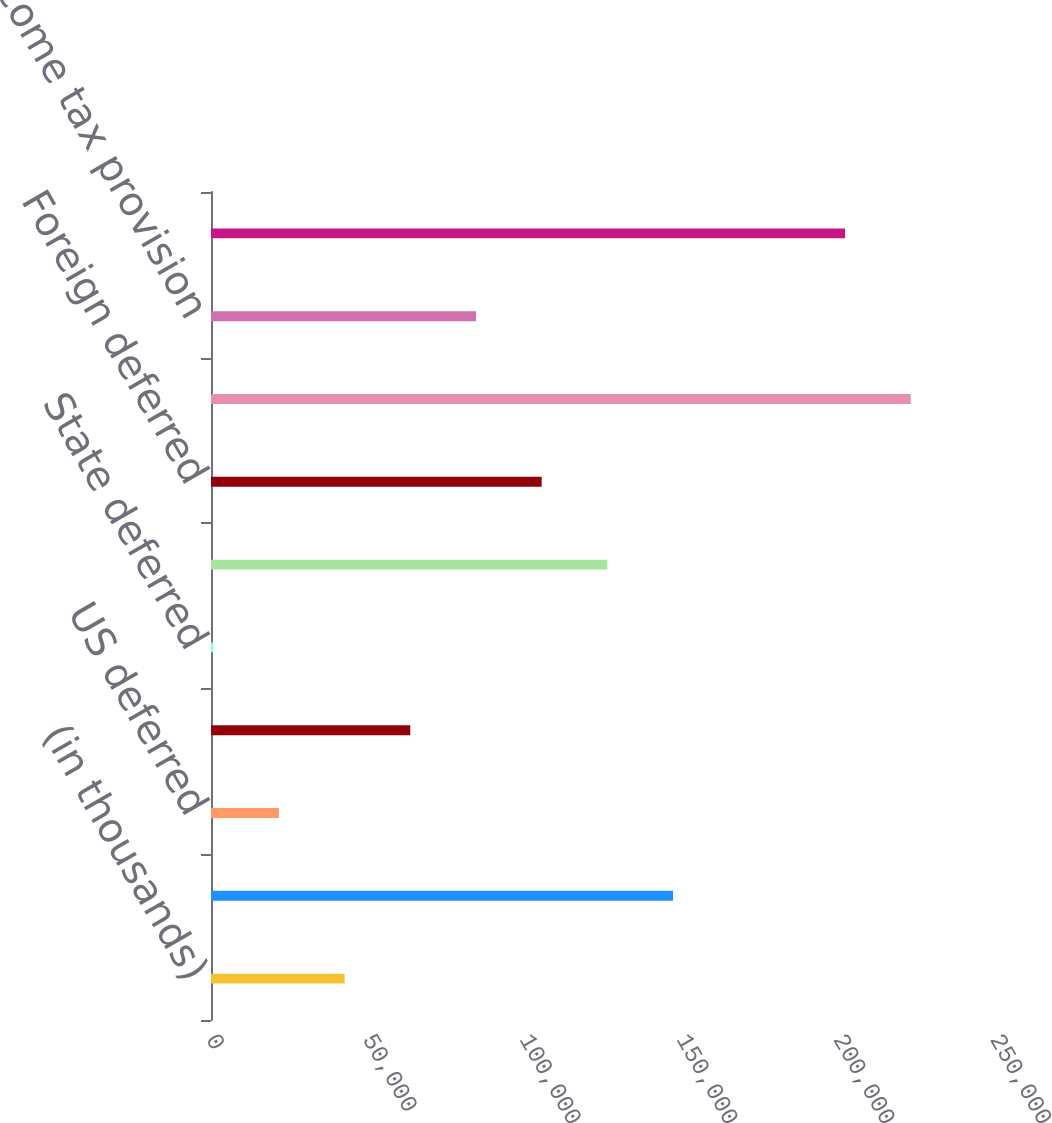Convert chart to OTSL. <chart><loc_0><loc_0><loc_500><loc_500><bar_chart><fcel>(in thousands)<fcel>US current<fcel>US deferred<fcel>State current<fcel>State deferred<fcel>Foreign current<fcel>Foreign deferred<fcel>Provision including<fcel>Income tax provision<fcel>Total income tax provision<nl><fcel>42600.2<fcel>147346<fcel>21651.1<fcel>63549.3<fcel>702<fcel>126397<fcel>105448<fcel>223140<fcel>84498.4<fcel>202191<nl></chart> 